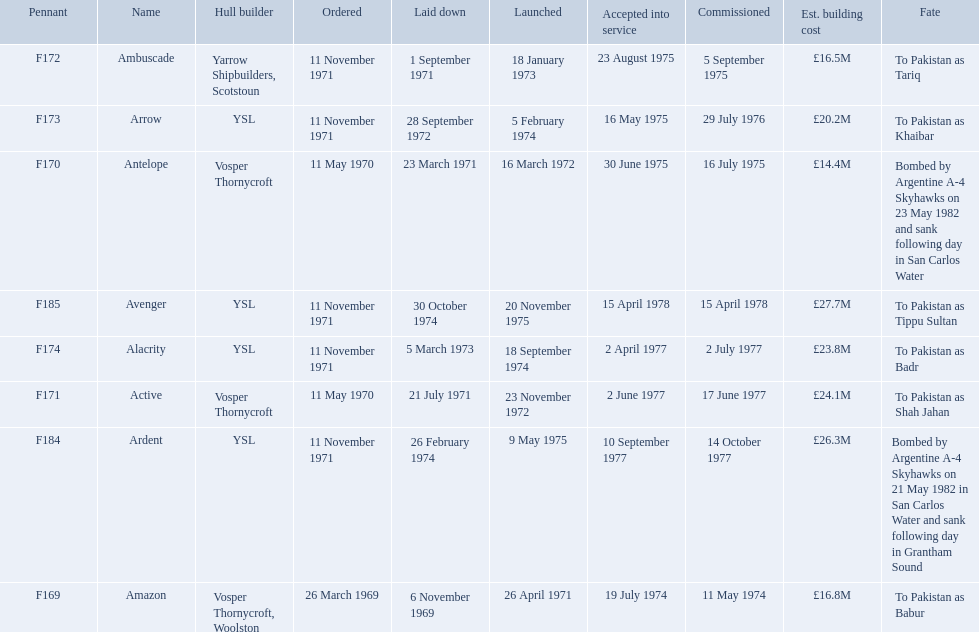What were the estimated building costs of the frigates? £16.8M, £14.4M, £16.5M, £20.2M, £24.1M, £23.8M, £26.3M, £27.7M. Which of these is the largest? £27.7M. What ship name does that correspond to? Avenger. 